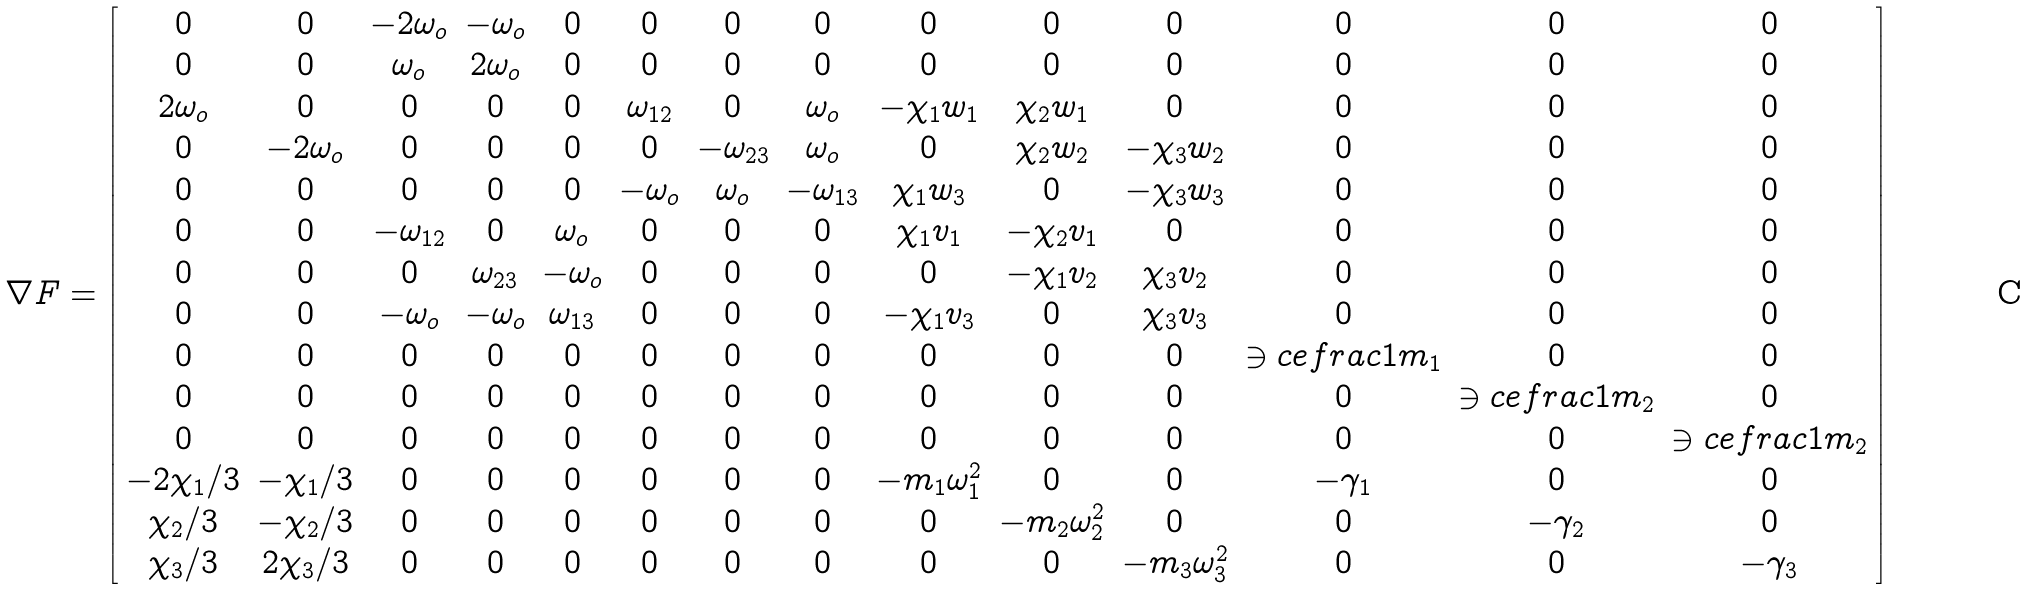<formula> <loc_0><loc_0><loc_500><loc_500>\nabla F = \left [ \begin{array} { c c c c c c c c c c c c c c } 0 & 0 & - 2 \omega _ { o } & - \omega _ { o } & 0 & 0 & 0 & 0 & 0 & 0 & 0 & 0 & 0 & 0 \\ 0 & 0 & \omega _ { o } & 2 \omega _ { o } & 0 & 0 & 0 & 0 & 0 & 0 & 0 & 0 & 0 & 0 \\ 2 \omega _ { o } & 0 & 0 & 0 & 0 & \omega _ { 1 2 } & 0 & \omega _ { o } & - \chi _ { 1 } w _ { 1 } & \chi _ { 2 } w _ { 1 } & 0 & 0 & 0 & 0 \\ 0 & - 2 \omega _ { o } & 0 & 0 & 0 & 0 & - \omega _ { 2 3 } & \omega _ { o } & 0 & \chi _ { 2 } w _ { 2 } & - \chi _ { 3 } w _ { 2 } & 0 & 0 & 0 \\ 0 & 0 & 0 & 0 & 0 & - \omega _ { o } & \omega _ { o } & - \omega _ { 1 3 } & \chi _ { 1 } w _ { 3 } & 0 & - \chi _ { 3 } w _ { 3 } & 0 & 0 & 0 \\ 0 & 0 & - \omega _ { 1 2 } & 0 & \omega _ { o } & 0 & 0 & 0 & \chi _ { 1 } v _ { 1 } & - \chi _ { 2 } v _ { 1 } & 0 & 0 & 0 & 0 \\ 0 & 0 & 0 & \omega _ { 2 3 } & - \omega _ { o } & 0 & 0 & 0 & 0 & - \chi _ { 1 } v _ { 2 } & \chi _ { 3 } v _ { 2 } & 0 & 0 & 0 \\ 0 & 0 & - \omega _ { o } & - \omega _ { o } & \omega _ { 1 3 } & 0 & 0 & 0 & - \chi _ { 1 } v _ { 3 } & 0 & \chi _ { 3 } v _ { 3 } & 0 & 0 & 0 \\ 0 & 0 & 0 & 0 & 0 & 0 & 0 & 0 & 0 & 0 & 0 & \ni c e f r a c 1 m _ { 1 } & 0 & 0 \\ 0 & 0 & 0 & 0 & 0 & 0 & 0 & 0 & 0 & 0 & 0 & 0 & \ni c e f r a c 1 m _ { 2 } & 0 \\ 0 & 0 & 0 & 0 & 0 & 0 & 0 & 0 & 0 & 0 & 0 & 0 & 0 & \ni c e f r a c 1 m _ { 2 } \\ - 2 \chi _ { 1 } / 3 & - \chi _ { 1 } / 3 & 0 & 0 & 0 & 0 & 0 & 0 & - m _ { 1 } \omega _ { 1 } ^ { 2 } & 0 & 0 & - \gamma _ { 1 } & 0 & 0 \\ \chi _ { 2 } / 3 & - \chi _ { 2 } / 3 & 0 & 0 & 0 & 0 & 0 & 0 & 0 & - m _ { 2 } \omega _ { 2 } ^ { 2 } & 0 & 0 & - \gamma _ { 2 } & 0 \\ \chi _ { 3 } / 3 & 2 \chi _ { 3 } / 3 & 0 & 0 & 0 & 0 & 0 & 0 & 0 & 0 & - m _ { 3 } \omega _ { 3 } ^ { 2 } & 0 & 0 & - \gamma _ { 3 } \end{array} \right ]</formula> 